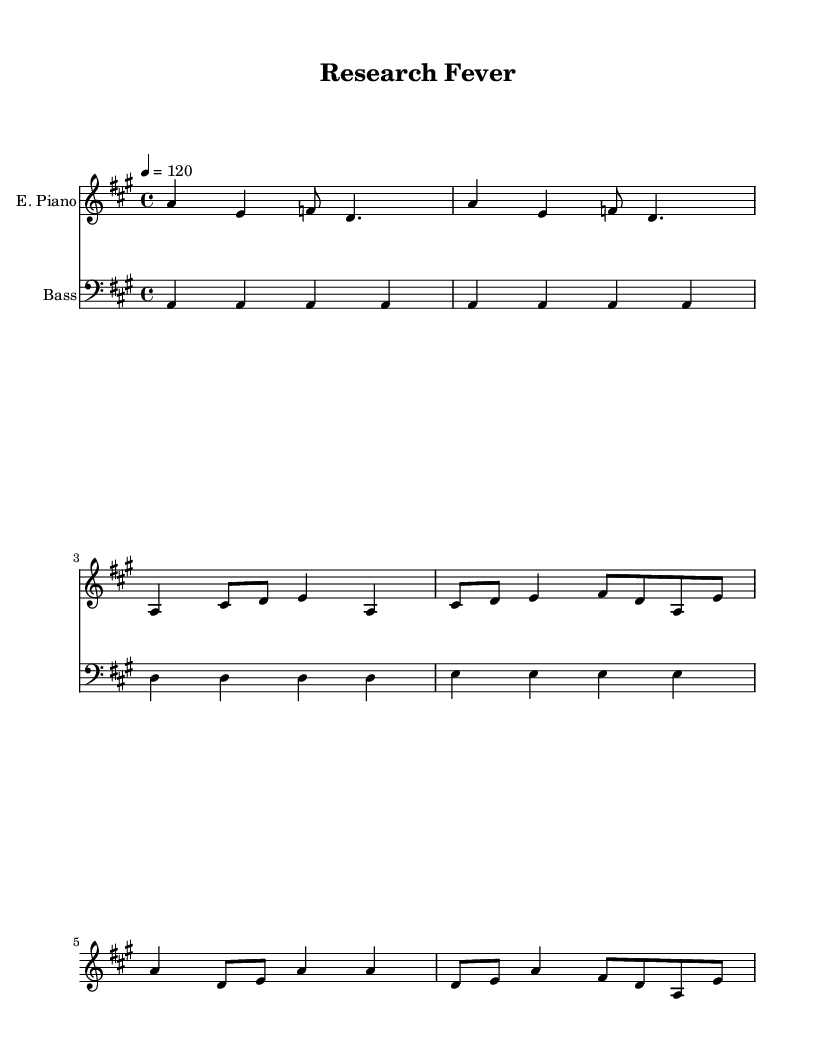What is the key signature of this music? The key signature is A major, which has three sharps: F#, C#, and G#.
Answer: A major What is the time signature of this music? The time signature is indicated at the beginning of the sheet music as 4/4, meaning there are four beats per measure.
Answer: 4/4 What is the tempo marking for this piece? The tempo marking is given as "4 = 120," which indicates that there are 120 quarter note beats per minute.
Answer: 120 How many measures are in the verse? The verse consists of two measures in total, which can be identified by looking at the verse section of the music.
Answer: 2 How does the bass line relate to the melody? The bass line provides a steady foundation, repeating with a consistent rhythmic pattern while the melody interacts by varying in pitch and rhythm above it. This supports the groove typical of disco music, creating a danceable quality.
Answer: It supports the melody What are the two instruments used in this piece? The two instruments used in this music are the electric piano and the bass guitar, as indicated by their respective staff names at the beginning of each section.
Answer: Electric Piano, Bass What type of harmony is primarily used in this disco track? The harmony primarily uses a simple, repetitive structure typical in disco, often based on major chords that enhance the uplifting and celebratory feel of the music.
Answer: Major chords 